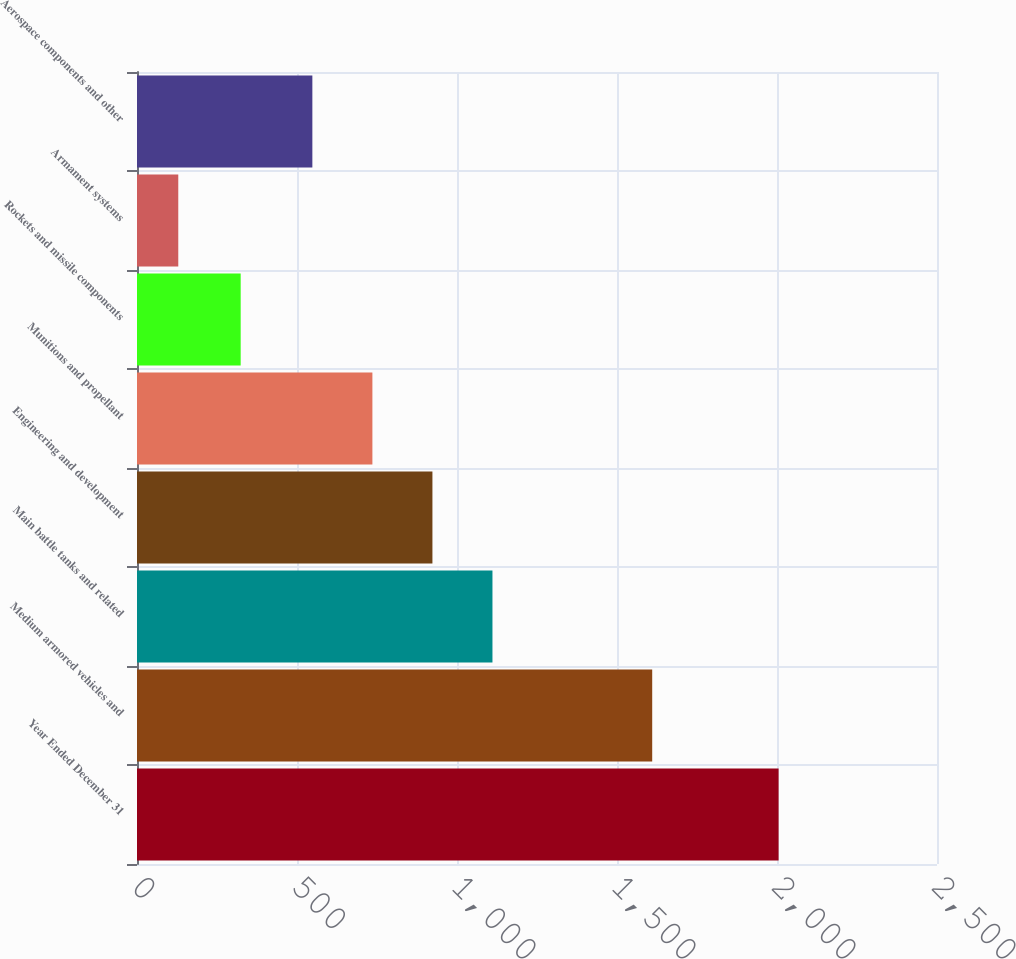Convert chart to OTSL. <chart><loc_0><loc_0><loc_500><loc_500><bar_chart><fcel>Year Ended December 31<fcel>Medium armored vehicles and<fcel>Main battle tanks and related<fcel>Engineering and development<fcel>Munitions and propellant<fcel>Rockets and missile components<fcel>Armament systems<fcel>Aerospace components and other<nl><fcel>2005<fcel>1610<fcel>1110.8<fcel>923.2<fcel>735.6<fcel>324<fcel>129<fcel>548<nl></chart> 